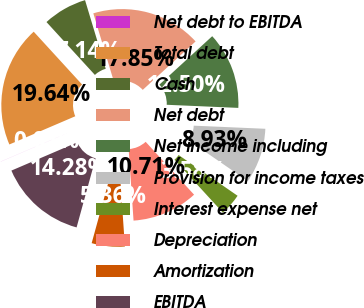Convert chart to OTSL. <chart><loc_0><loc_0><loc_500><loc_500><pie_chart><fcel>Net debt to EBITDA<fcel>Total debt<fcel>Cash<fcel>Net debt<fcel>Net income including<fcel>Provision for income taxes<fcel>Interest expense net<fcel>Depreciation<fcel>Amortization<fcel>EBITDA<nl><fcel>0.01%<fcel>19.64%<fcel>7.14%<fcel>17.85%<fcel>12.5%<fcel>8.93%<fcel>3.58%<fcel>10.71%<fcel>5.36%<fcel>14.28%<nl></chart> 